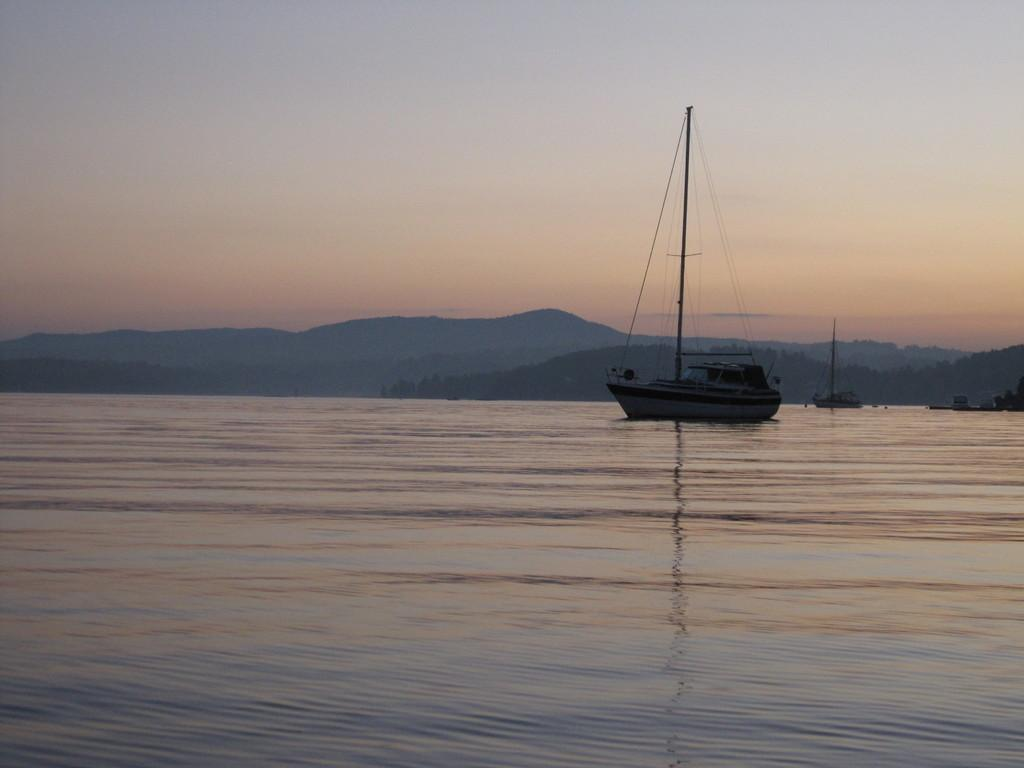What is the main subject of the image? The main subject of the image is a boat. Where is the boat located? The boat is on the surface of a river. What can be seen in the background of the image? There are hills visible in the background of the image. What is visible above the boat? The sky is visible in the image. What type of fruit is hanging from the trees in the aftermath of the journey? There is no fruit hanging from the trees in the image, nor is there any mention of a journey or its aftermath. 